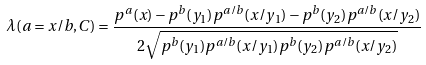<formula> <loc_0><loc_0><loc_500><loc_500>\lambda ( a = x / b , C ) = \frac { p ^ { a } ( x ) - p ^ { b } ( y _ { 1 } ) p ^ { a / b } ( x / y _ { 1 } ) - p ^ { b } ( y _ { 2 } ) p ^ { a / b } ( x / y _ { 2 } ) } { 2 \sqrt { p ^ { b } ( y _ { 1 } ) p ^ { a / b } ( x / y _ { 1 } ) p ^ { b } ( y _ { 2 } ) p ^ { a / b } ( x / y _ { 2 } ) } }</formula> 